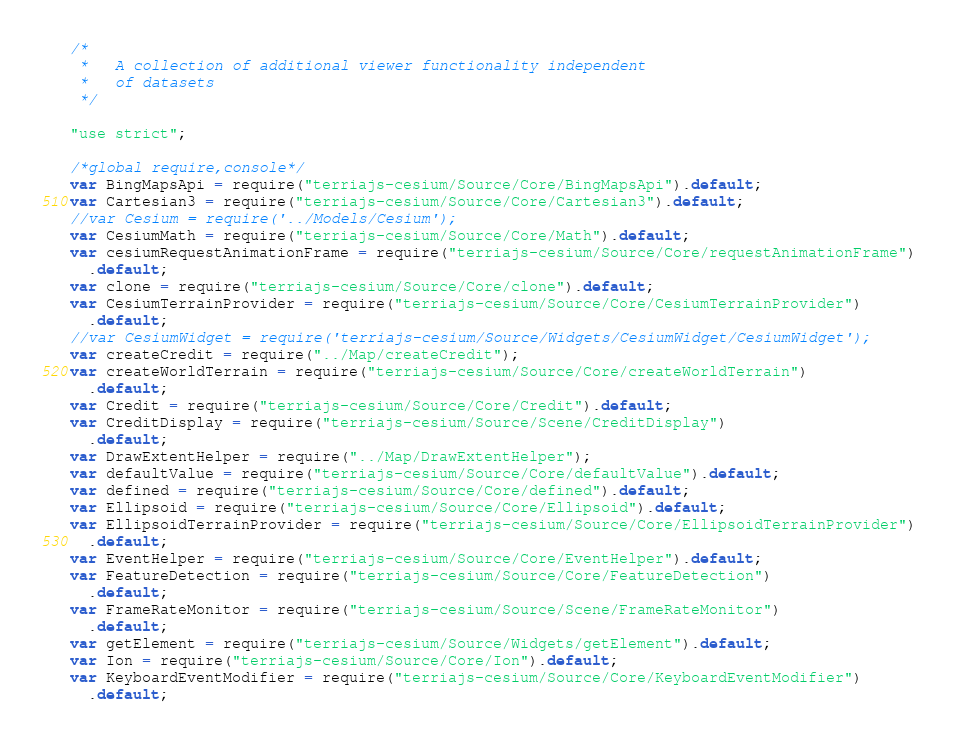Convert code to text. <code><loc_0><loc_0><loc_500><loc_500><_JavaScript_>/*
 *   A collection of additional viewer functionality independent
 *   of datasets
 */

"use strict";

/*global require,console*/
var BingMapsApi = require("terriajs-cesium/Source/Core/BingMapsApi").default;
var Cartesian3 = require("terriajs-cesium/Source/Core/Cartesian3").default;
//var Cesium = require('../Models/Cesium');
var CesiumMath = require("terriajs-cesium/Source/Core/Math").default;
var cesiumRequestAnimationFrame = require("terriajs-cesium/Source/Core/requestAnimationFrame")
  .default;
var clone = require("terriajs-cesium/Source/Core/clone").default;
var CesiumTerrainProvider = require("terriajs-cesium/Source/Core/CesiumTerrainProvider")
  .default;
//var CesiumWidget = require('terriajs-cesium/Source/Widgets/CesiumWidget/CesiumWidget');
var createCredit = require("../Map/createCredit");
var createWorldTerrain = require("terriajs-cesium/Source/Core/createWorldTerrain")
  .default;
var Credit = require("terriajs-cesium/Source/Core/Credit").default;
var CreditDisplay = require("terriajs-cesium/Source/Scene/CreditDisplay")
  .default;
var DrawExtentHelper = require("../Map/DrawExtentHelper");
var defaultValue = require("terriajs-cesium/Source/Core/defaultValue").default;
var defined = require("terriajs-cesium/Source/Core/defined").default;
var Ellipsoid = require("terriajs-cesium/Source/Core/Ellipsoid").default;
var EllipsoidTerrainProvider = require("terriajs-cesium/Source/Core/EllipsoidTerrainProvider")
  .default;
var EventHelper = require("terriajs-cesium/Source/Core/EventHelper").default;
var FeatureDetection = require("terriajs-cesium/Source/Core/FeatureDetection")
  .default;
var FrameRateMonitor = require("terriajs-cesium/Source/Scene/FrameRateMonitor")
  .default;
var getElement = require("terriajs-cesium/Source/Widgets/getElement").default;
var Ion = require("terriajs-cesium/Source/Core/Ion").default;
var KeyboardEventModifier = require("terriajs-cesium/Source/Core/KeyboardEventModifier")
  .default;</code> 